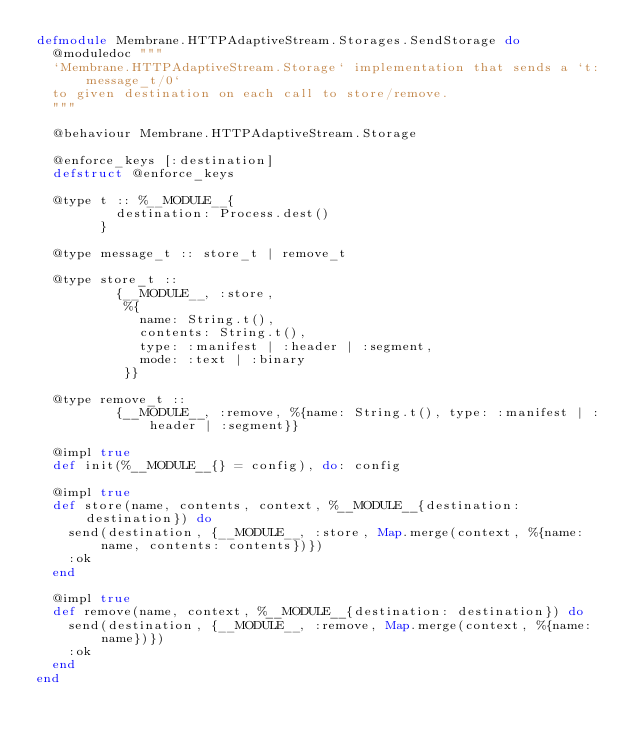<code> <loc_0><loc_0><loc_500><loc_500><_Elixir_>defmodule Membrane.HTTPAdaptiveStream.Storages.SendStorage do
  @moduledoc """
  `Membrane.HTTPAdaptiveStream.Storage` implementation that sends a `t:message_t/0`
  to given destination on each call to store/remove.
  """

  @behaviour Membrane.HTTPAdaptiveStream.Storage

  @enforce_keys [:destination]
  defstruct @enforce_keys

  @type t :: %__MODULE__{
          destination: Process.dest()
        }

  @type message_t :: store_t | remove_t

  @type store_t ::
          {__MODULE__, :store,
           %{
             name: String.t(),
             contents: String.t(),
             type: :manifest | :header | :segment,
             mode: :text | :binary
           }}

  @type remove_t ::
          {__MODULE__, :remove, %{name: String.t(), type: :manifest | :header | :segment}}

  @impl true
  def init(%__MODULE__{} = config), do: config

  @impl true
  def store(name, contents, context, %__MODULE__{destination: destination}) do
    send(destination, {__MODULE__, :store, Map.merge(context, %{name: name, contents: contents})})
    :ok
  end

  @impl true
  def remove(name, context, %__MODULE__{destination: destination}) do
    send(destination, {__MODULE__, :remove, Map.merge(context, %{name: name})})
    :ok
  end
end
</code> 